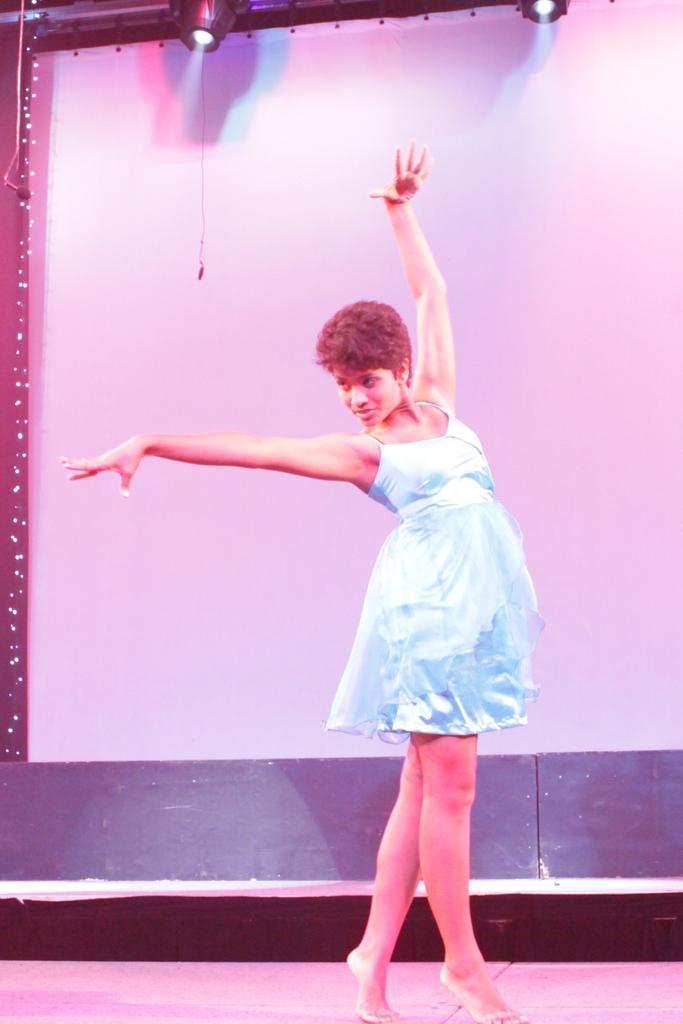In one or two sentences, can you explain what this image depicts? In the middle of the picture, the girl in blue dress is dancing on the stage. Behind her, it looks like a bench. In the background, we see a white wall or a sheet. At the top of the picture, we see the lights. 